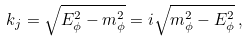Convert formula to latex. <formula><loc_0><loc_0><loc_500><loc_500>k _ { j } = \sqrt { E _ { \phi } ^ { 2 } - m _ { \phi } ^ { 2 } } = i \sqrt { m _ { \phi } ^ { 2 } - E _ { \phi } ^ { 2 } } \, ,</formula> 